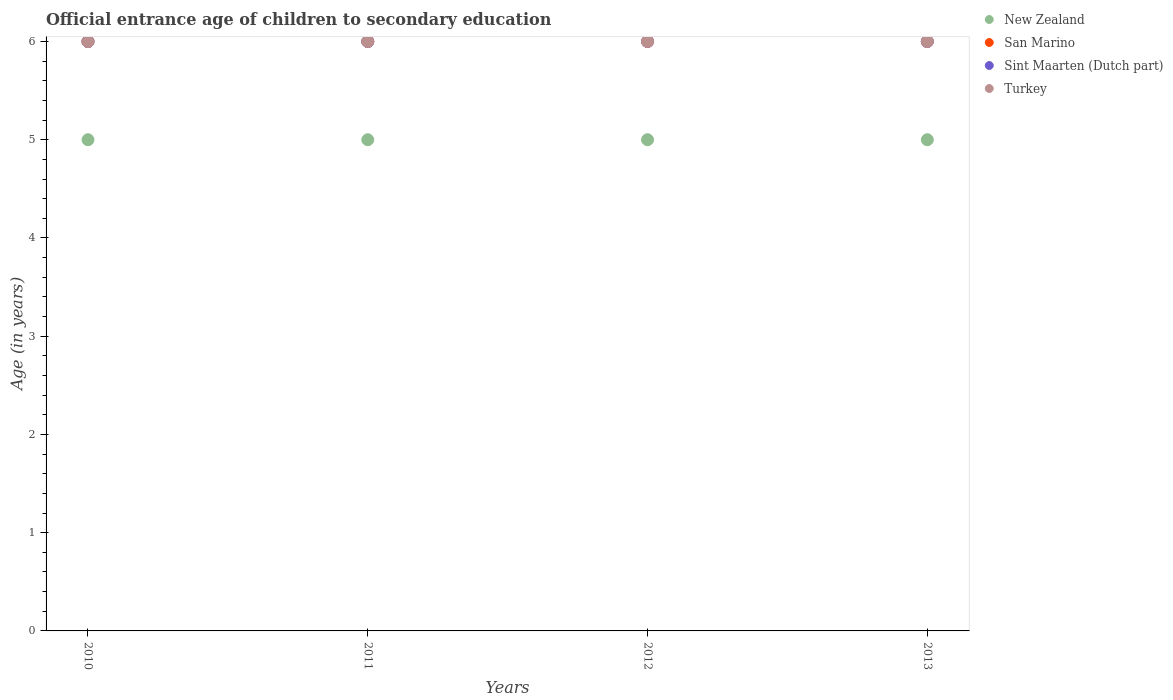How many different coloured dotlines are there?
Make the answer very short. 4. Across all years, what is the maximum secondary school starting age of children in Turkey?
Offer a very short reply. 6. Across all years, what is the minimum secondary school starting age of children in New Zealand?
Offer a terse response. 5. In which year was the secondary school starting age of children in San Marino maximum?
Give a very brief answer. 2010. What is the total secondary school starting age of children in Turkey in the graph?
Your answer should be compact. 24. What is the difference between the secondary school starting age of children in New Zealand in 2013 and the secondary school starting age of children in Sint Maarten (Dutch part) in 2010?
Provide a succinct answer. -1. What is the ratio of the secondary school starting age of children in San Marino in 2010 to that in 2012?
Make the answer very short. 1. Is the difference between the secondary school starting age of children in San Marino in 2010 and 2012 greater than the difference between the secondary school starting age of children in Turkey in 2010 and 2012?
Ensure brevity in your answer.  No. What is the difference between the highest and the second highest secondary school starting age of children in Turkey?
Offer a very short reply. 0. What is the difference between the highest and the lowest secondary school starting age of children in New Zealand?
Offer a very short reply. 0. In how many years, is the secondary school starting age of children in New Zealand greater than the average secondary school starting age of children in New Zealand taken over all years?
Give a very brief answer. 0. Is the sum of the secondary school starting age of children in New Zealand in 2012 and 2013 greater than the maximum secondary school starting age of children in Turkey across all years?
Provide a short and direct response. Yes. Is it the case that in every year, the sum of the secondary school starting age of children in San Marino and secondary school starting age of children in New Zealand  is greater than the sum of secondary school starting age of children in Sint Maarten (Dutch part) and secondary school starting age of children in Turkey?
Keep it short and to the point. No. Does the secondary school starting age of children in New Zealand monotonically increase over the years?
Provide a short and direct response. No. Is the secondary school starting age of children in San Marino strictly greater than the secondary school starting age of children in Sint Maarten (Dutch part) over the years?
Offer a terse response. No. How many dotlines are there?
Give a very brief answer. 4. How many years are there in the graph?
Keep it short and to the point. 4. What is the difference between two consecutive major ticks on the Y-axis?
Your answer should be compact. 1. Are the values on the major ticks of Y-axis written in scientific E-notation?
Your answer should be very brief. No. Does the graph contain grids?
Provide a succinct answer. No. Where does the legend appear in the graph?
Keep it short and to the point. Top right. How many legend labels are there?
Your answer should be very brief. 4. What is the title of the graph?
Offer a very short reply. Official entrance age of children to secondary education. What is the label or title of the Y-axis?
Your answer should be very brief. Age (in years). What is the Age (in years) in Sint Maarten (Dutch part) in 2010?
Make the answer very short. 6. What is the Age (in years) in New Zealand in 2011?
Your answer should be compact. 5. What is the Age (in years) of Sint Maarten (Dutch part) in 2011?
Make the answer very short. 6. Across all years, what is the maximum Age (in years) in New Zealand?
Keep it short and to the point. 5. Across all years, what is the maximum Age (in years) of San Marino?
Provide a succinct answer. 6. Across all years, what is the maximum Age (in years) of Sint Maarten (Dutch part)?
Give a very brief answer. 6. Across all years, what is the minimum Age (in years) of New Zealand?
Offer a very short reply. 5. Across all years, what is the minimum Age (in years) in Sint Maarten (Dutch part)?
Offer a terse response. 6. Across all years, what is the minimum Age (in years) in Turkey?
Your answer should be very brief. 6. What is the total Age (in years) of Turkey in the graph?
Your response must be concise. 24. What is the difference between the Age (in years) of New Zealand in 2010 and that in 2011?
Ensure brevity in your answer.  0. What is the difference between the Age (in years) of San Marino in 2010 and that in 2011?
Keep it short and to the point. 0. What is the difference between the Age (in years) in New Zealand in 2010 and that in 2012?
Your answer should be compact. 0. What is the difference between the Age (in years) in San Marino in 2010 and that in 2013?
Your response must be concise. 0. What is the difference between the Age (in years) in Turkey in 2010 and that in 2013?
Provide a short and direct response. 0. What is the difference between the Age (in years) in New Zealand in 2011 and that in 2012?
Ensure brevity in your answer.  0. What is the difference between the Age (in years) in San Marino in 2011 and that in 2012?
Provide a short and direct response. 0. What is the difference between the Age (in years) of Sint Maarten (Dutch part) in 2011 and that in 2012?
Offer a very short reply. 0. What is the difference between the Age (in years) in New Zealand in 2011 and that in 2013?
Provide a succinct answer. 0. What is the difference between the Age (in years) of Sint Maarten (Dutch part) in 2011 and that in 2013?
Offer a terse response. 0. What is the difference between the Age (in years) of Sint Maarten (Dutch part) in 2012 and that in 2013?
Provide a succinct answer. 0. What is the difference between the Age (in years) of Turkey in 2012 and that in 2013?
Offer a very short reply. 0. What is the difference between the Age (in years) in New Zealand in 2010 and the Age (in years) in San Marino in 2011?
Make the answer very short. -1. What is the difference between the Age (in years) of New Zealand in 2010 and the Age (in years) of Sint Maarten (Dutch part) in 2011?
Ensure brevity in your answer.  -1. What is the difference between the Age (in years) of San Marino in 2010 and the Age (in years) of Sint Maarten (Dutch part) in 2011?
Provide a short and direct response. 0. What is the difference between the Age (in years) in San Marino in 2010 and the Age (in years) in Turkey in 2011?
Ensure brevity in your answer.  0. What is the difference between the Age (in years) in New Zealand in 2010 and the Age (in years) in San Marino in 2012?
Offer a very short reply. -1. What is the difference between the Age (in years) in New Zealand in 2010 and the Age (in years) in Turkey in 2012?
Give a very brief answer. -1. What is the difference between the Age (in years) of San Marino in 2010 and the Age (in years) of Sint Maarten (Dutch part) in 2012?
Make the answer very short. 0. What is the difference between the Age (in years) in San Marino in 2010 and the Age (in years) in Turkey in 2012?
Your answer should be compact. 0. What is the difference between the Age (in years) of Sint Maarten (Dutch part) in 2010 and the Age (in years) of Turkey in 2012?
Offer a terse response. 0. What is the difference between the Age (in years) in New Zealand in 2010 and the Age (in years) in San Marino in 2013?
Give a very brief answer. -1. What is the difference between the Age (in years) in New Zealand in 2010 and the Age (in years) in Sint Maarten (Dutch part) in 2013?
Your response must be concise. -1. What is the difference between the Age (in years) of New Zealand in 2010 and the Age (in years) of Turkey in 2013?
Offer a terse response. -1. What is the difference between the Age (in years) of New Zealand in 2011 and the Age (in years) of Sint Maarten (Dutch part) in 2012?
Offer a terse response. -1. What is the difference between the Age (in years) in New Zealand in 2011 and the Age (in years) in Turkey in 2012?
Offer a terse response. -1. What is the difference between the Age (in years) in Sint Maarten (Dutch part) in 2011 and the Age (in years) in Turkey in 2012?
Keep it short and to the point. 0. What is the difference between the Age (in years) in New Zealand in 2011 and the Age (in years) in San Marino in 2013?
Make the answer very short. -1. What is the difference between the Age (in years) in New Zealand in 2011 and the Age (in years) in Turkey in 2013?
Give a very brief answer. -1. What is the difference between the Age (in years) of New Zealand in 2012 and the Age (in years) of San Marino in 2013?
Give a very brief answer. -1. What is the difference between the Age (in years) in New Zealand in 2012 and the Age (in years) in Turkey in 2013?
Provide a succinct answer. -1. What is the difference between the Age (in years) of San Marino in 2012 and the Age (in years) of Turkey in 2013?
Your response must be concise. 0. What is the difference between the Age (in years) of Sint Maarten (Dutch part) in 2012 and the Age (in years) of Turkey in 2013?
Give a very brief answer. 0. What is the average Age (in years) in San Marino per year?
Make the answer very short. 6. What is the average Age (in years) in Sint Maarten (Dutch part) per year?
Your answer should be very brief. 6. What is the average Age (in years) in Turkey per year?
Offer a terse response. 6. In the year 2010, what is the difference between the Age (in years) in New Zealand and Age (in years) in Turkey?
Your answer should be very brief. -1. In the year 2010, what is the difference between the Age (in years) of San Marino and Age (in years) of Sint Maarten (Dutch part)?
Make the answer very short. 0. In the year 2010, what is the difference between the Age (in years) in Sint Maarten (Dutch part) and Age (in years) in Turkey?
Offer a terse response. 0. In the year 2011, what is the difference between the Age (in years) of San Marino and Age (in years) of Turkey?
Offer a terse response. 0. In the year 2012, what is the difference between the Age (in years) in New Zealand and Age (in years) in San Marino?
Provide a short and direct response. -1. In the year 2012, what is the difference between the Age (in years) in New Zealand and Age (in years) in Sint Maarten (Dutch part)?
Your answer should be compact. -1. In the year 2013, what is the difference between the Age (in years) in New Zealand and Age (in years) in San Marino?
Ensure brevity in your answer.  -1. In the year 2013, what is the difference between the Age (in years) in New Zealand and Age (in years) in Sint Maarten (Dutch part)?
Provide a short and direct response. -1. In the year 2013, what is the difference between the Age (in years) of New Zealand and Age (in years) of Turkey?
Make the answer very short. -1. In the year 2013, what is the difference between the Age (in years) in San Marino and Age (in years) in Sint Maarten (Dutch part)?
Make the answer very short. 0. In the year 2013, what is the difference between the Age (in years) of Sint Maarten (Dutch part) and Age (in years) of Turkey?
Provide a succinct answer. 0. What is the ratio of the Age (in years) of Sint Maarten (Dutch part) in 2010 to that in 2011?
Give a very brief answer. 1. What is the ratio of the Age (in years) of San Marino in 2010 to that in 2012?
Offer a very short reply. 1. What is the ratio of the Age (in years) of Sint Maarten (Dutch part) in 2010 to that in 2012?
Your answer should be very brief. 1. What is the ratio of the Age (in years) in Turkey in 2010 to that in 2012?
Keep it short and to the point. 1. What is the ratio of the Age (in years) of San Marino in 2010 to that in 2013?
Keep it short and to the point. 1. What is the ratio of the Age (in years) of Sint Maarten (Dutch part) in 2010 to that in 2013?
Offer a very short reply. 1. What is the ratio of the Age (in years) in Turkey in 2010 to that in 2013?
Keep it short and to the point. 1. What is the ratio of the Age (in years) in San Marino in 2011 to that in 2012?
Ensure brevity in your answer.  1. What is the ratio of the Age (in years) in Turkey in 2011 to that in 2012?
Your answer should be very brief. 1. What is the ratio of the Age (in years) of New Zealand in 2011 to that in 2013?
Offer a very short reply. 1. What is the ratio of the Age (in years) of Sint Maarten (Dutch part) in 2011 to that in 2013?
Offer a very short reply. 1. What is the ratio of the Age (in years) of Turkey in 2011 to that in 2013?
Offer a terse response. 1. What is the ratio of the Age (in years) in New Zealand in 2012 to that in 2013?
Offer a very short reply. 1. What is the ratio of the Age (in years) of Turkey in 2012 to that in 2013?
Your answer should be compact. 1. What is the difference between the highest and the second highest Age (in years) of New Zealand?
Ensure brevity in your answer.  0. What is the difference between the highest and the second highest Age (in years) in San Marino?
Your answer should be compact. 0. What is the difference between the highest and the lowest Age (in years) in New Zealand?
Provide a succinct answer. 0. What is the difference between the highest and the lowest Age (in years) in San Marino?
Ensure brevity in your answer.  0. 